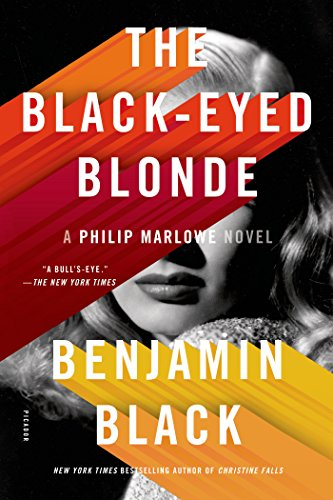Who wrote this book? The book 'The Black-Eyed Blonde' is authored by Benjamin Black, a pseudonym used by the well-known writer John Banville for writing noir fiction. 